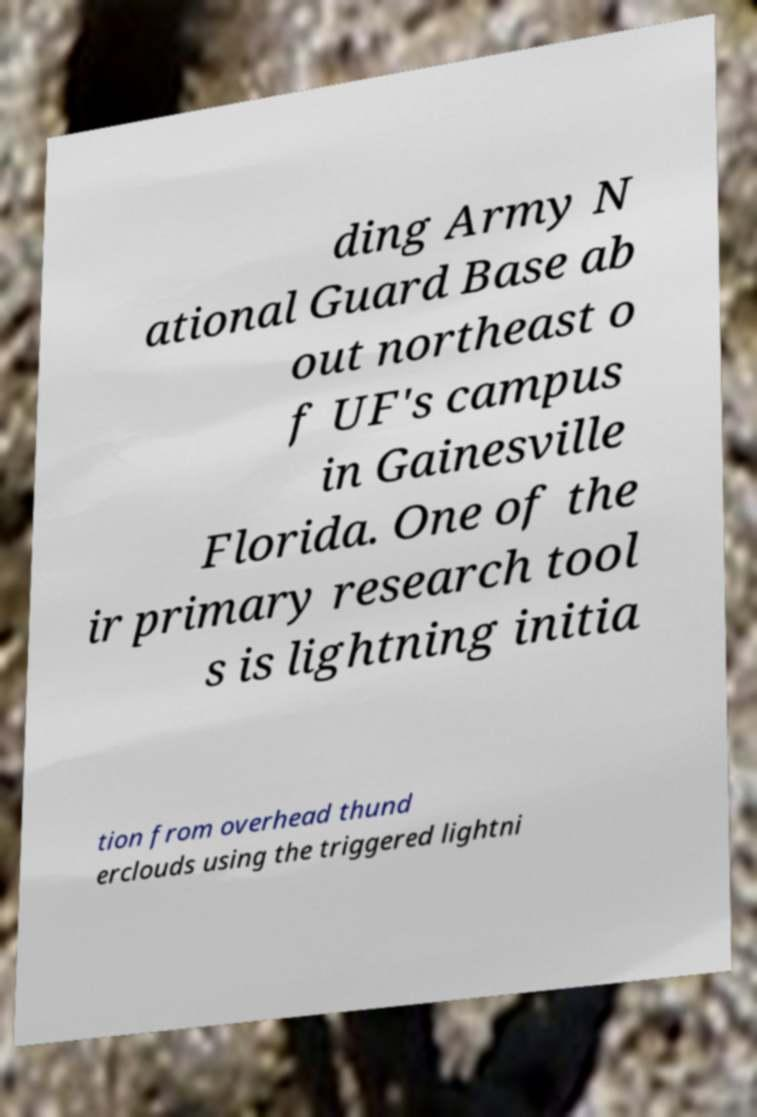Could you assist in decoding the text presented in this image and type it out clearly? ding Army N ational Guard Base ab out northeast o f UF's campus in Gainesville Florida. One of the ir primary research tool s is lightning initia tion from overhead thund erclouds using the triggered lightni 